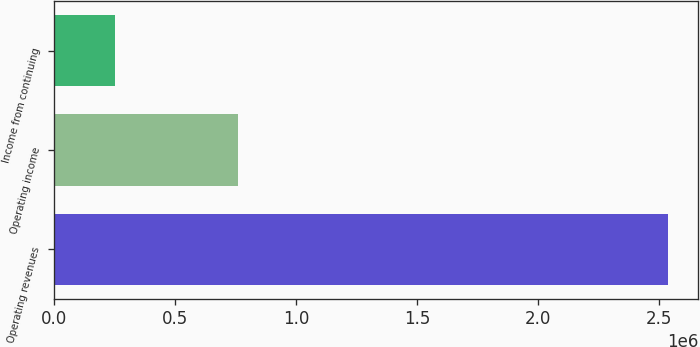Convert chart to OTSL. <chart><loc_0><loc_0><loc_500><loc_500><bar_chart><fcel>Operating revenues<fcel>Operating income<fcel>Income from continuing<nl><fcel>2.53513e+06<fcel>760540<fcel>253514<nl></chart> 